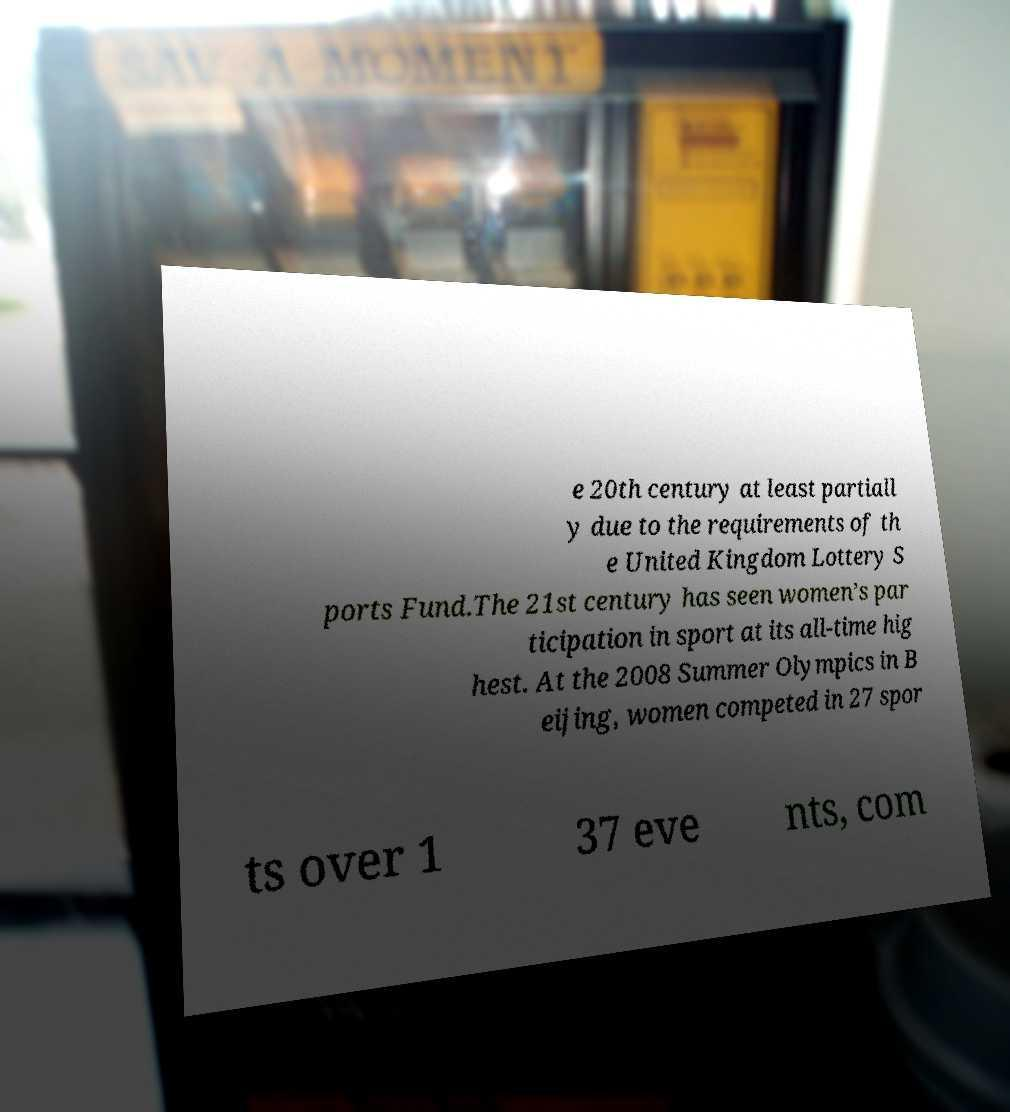Please read and relay the text visible in this image. What does it say? e 20th century at least partiall y due to the requirements of th e United Kingdom Lottery S ports Fund.The 21st century has seen women’s par ticipation in sport at its all-time hig hest. At the 2008 Summer Olympics in B eijing, women competed in 27 spor ts over 1 37 eve nts, com 